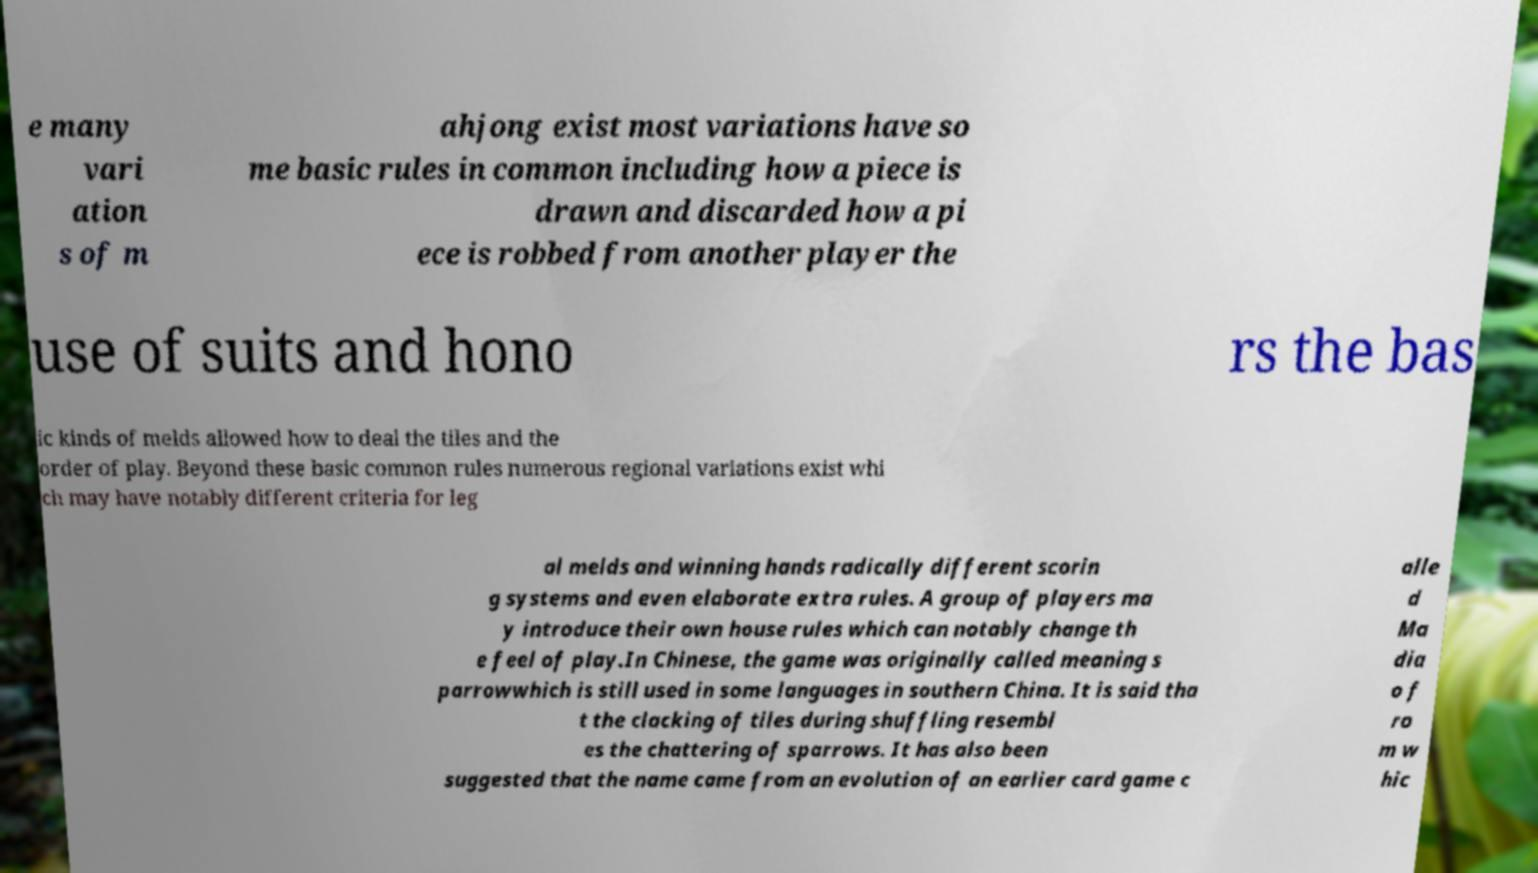Please identify and transcribe the text found in this image. e many vari ation s of m ahjong exist most variations have so me basic rules in common including how a piece is drawn and discarded how a pi ece is robbed from another player the use of suits and hono rs the bas ic kinds of melds allowed how to deal the tiles and the order of play. Beyond these basic common rules numerous regional variations exist whi ch may have notably different criteria for leg al melds and winning hands radically different scorin g systems and even elaborate extra rules. A group of players ma y introduce their own house rules which can notably change th e feel of play.In Chinese, the game was originally called meaning s parrowwhich is still used in some languages in southern China. It is said tha t the clacking of tiles during shuffling resembl es the chattering of sparrows. It has also been suggested that the name came from an evolution of an earlier card game c alle d Ma dia o f ro m w hic 